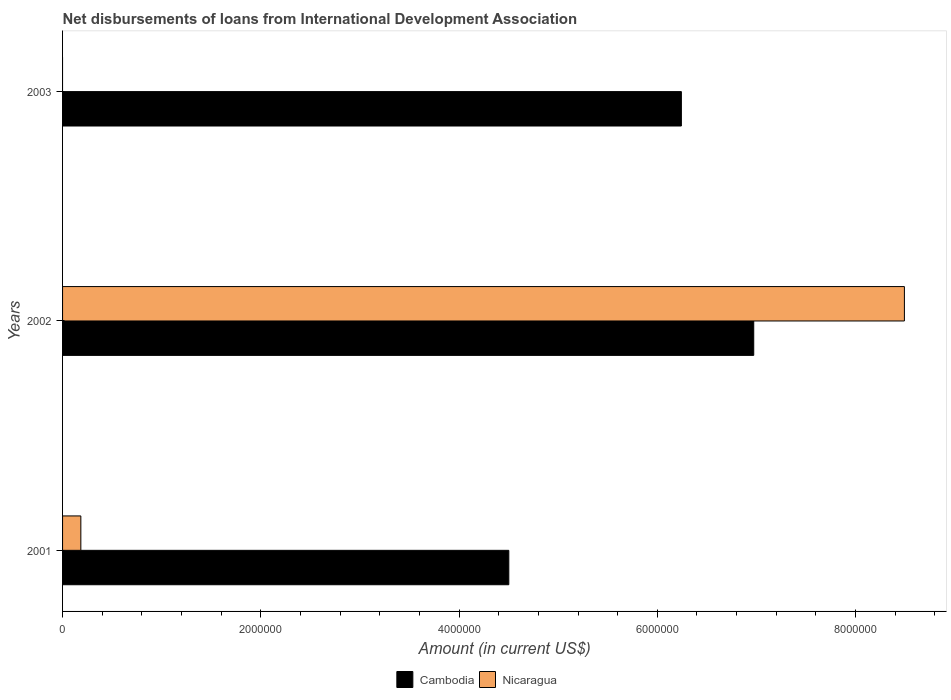Are the number of bars on each tick of the Y-axis equal?
Provide a short and direct response. No. How many bars are there on the 2nd tick from the top?
Your answer should be very brief. 2. How many bars are there on the 1st tick from the bottom?
Offer a terse response. 2. What is the label of the 3rd group of bars from the top?
Provide a succinct answer. 2001. In how many cases, is the number of bars for a given year not equal to the number of legend labels?
Give a very brief answer. 1. What is the amount of loans disbursed in Nicaragua in 2002?
Keep it short and to the point. 8.49e+06. Across all years, what is the maximum amount of loans disbursed in Cambodia?
Your answer should be compact. 6.97e+06. What is the total amount of loans disbursed in Nicaragua in the graph?
Your answer should be very brief. 8.68e+06. What is the difference between the amount of loans disbursed in Cambodia in 2002 and that in 2003?
Your response must be concise. 7.30e+05. What is the difference between the amount of loans disbursed in Nicaragua in 2001 and the amount of loans disbursed in Cambodia in 2002?
Your answer should be compact. -6.79e+06. What is the average amount of loans disbursed in Cambodia per year?
Keep it short and to the point. 5.91e+06. In the year 2001, what is the difference between the amount of loans disbursed in Nicaragua and amount of loans disbursed in Cambodia?
Provide a succinct answer. -4.32e+06. In how many years, is the amount of loans disbursed in Cambodia greater than 5200000 US$?
Offer a very short reply. 2. What is the ratio of the amount of loans disbursed in Nicaragua in 2001 to that in 2002?
Your answer should be compact. 0.02. Is the amount of loans disbursed in Cambodia in 2001 less than that in 2003?
Ensure brevity in your answer.  Yes. What is the difference between the highest and the second highest amount of loans disbursed in Cambodia?
Provide a short and direct response. 7.30e+05. What is the difference between the highest and the lowest amount of loans disbursed in Nicaragua?
Give a very brief answer. 8.49e+06. In how many years, is the amount of loans disbursed in Nicaragua greater than the average amount of loans disbursed in Nicaragua taken over all years?
Provide a short and direct response. 1. Is the sum of the amount of loans disbursed in Cambodia in 2001 and 2003 greater than the maximum amount of loans disbursed in Nicaragua across all years?
Ensure brevity in your answer.  Yes. Does the graph contain any zero values?
Provide a short and direct response. Yes. How are the legend labels stacked?
Offer a terse response. Horizontal. What is the title of the graph?
Your response must be concise. Net disbursements of loans from International Development Association. What is the Amount (in current US$) of Cambodia in 2001?
Your answer should be very brief. 4.50e+06. What is the Amount (in current US$) in Nicaragua in 2001?
Offer a very short reply. 1.84e+05. What is the Amount (in current US$) of Cambodia in 2002?
Your answer should be very brief. 6.97e+06. What is the Amount (in current US$) of Nicaragua in 2002?
Provide a short and direct response. 8.49e+06. What is the Amount (in current US$) of Cambodia in 2003?
Your answer should be compact. 6.24e+06. Across all years, what is the maximum Amount (in current US$) in Cambodia?
Provide a short and direct response. 6.97e+06. Across all years, what is the maximum Amount (in current US$) in Nicaragua?
Provide a succinct answer. 8.49e+06. Across all years, what is the minimum Amount (in current US$) of Cambodia?
Offer a very short reply. 4.50e+06. What is the total Amount (in current US$) in Cambodia in the graph?
Provide a short and direct response. 1.77e+07. What is the total Amount (in current US$) in Nicaragua in the graph?
Make the answer very short. 8.68e+06. What is the difference between the Amount (in current US$) in Cambodia in 2001 and that in 2002?
Your response must be concise. -2.47e+06. What is the difference between the Amount (in current US$) in Nicaragua in 2001 and that in 2002?
Your answer should be very brief. -8.31e+06. What is the difference between the Amount (in current US$) in Cambodia in 2001 and that in 2003?
Give a very brief answer. -1.74e+06. What is the difference between the Amount (in current US$) of Cambodia in 2002 and that in 2003?
Your answer should be compact. 7.30e+05. What is the difference between the Amount (in current US$) in Cambodia in 2001 and the Amount (in current US$) in Nicaragua in 2002?
Your response must be concise. -3.99e+06. What is the average Amount (in current US$) of Cambodia per year?
Make the answer very short. 5.91e+06. What is the average Amount (in current US$) in Nicaragua per year?
Your answer should be compact. 2.89e+06. In the year 2001, what is the difference between the Amount (in current US$) in Cambodia and Amount (in current US$) in Nicaragua?
Offer a very short reply. 4.32e+06. In the year 2002, what is the difference between the Amount (in current US$) in Cambodia and Amount (in current US$) in Nicaragua?
Your answer should be compact. -1.52e+06. What is the ratio of the Amount (in current US$) in Cambodia in 2001 to that in 2002?
Ensure brevity in your answer.  0.65. What is the ratio of the Amount (in current US$) of Nicaragua in 2001 to that in 2002?
Ensure brevity in your answer.  0.02. What is the ratio of the Amount (in current US$) in Cambodia in 2001 to that in 2003?
Your response must be concise. 0.72. What is the ratio of the Amount (in current US$) in Cambodia in 2002 to that in 2003?
Offer a terse response. 1.12. What is the difference between the highest and the second highest Amount (in current US$) in Cambodia?
Keep it short and to the point. 7.30e+05. What is the difference between the highest and the lowest Amount (in current US$) of Cambodia?
Give a very brief answer. 2.47e+06. What is the difference between the highest and the lowest Amount (in current US$) in Nicaragua?
Keep it short and to the point. 8.49e+06. 